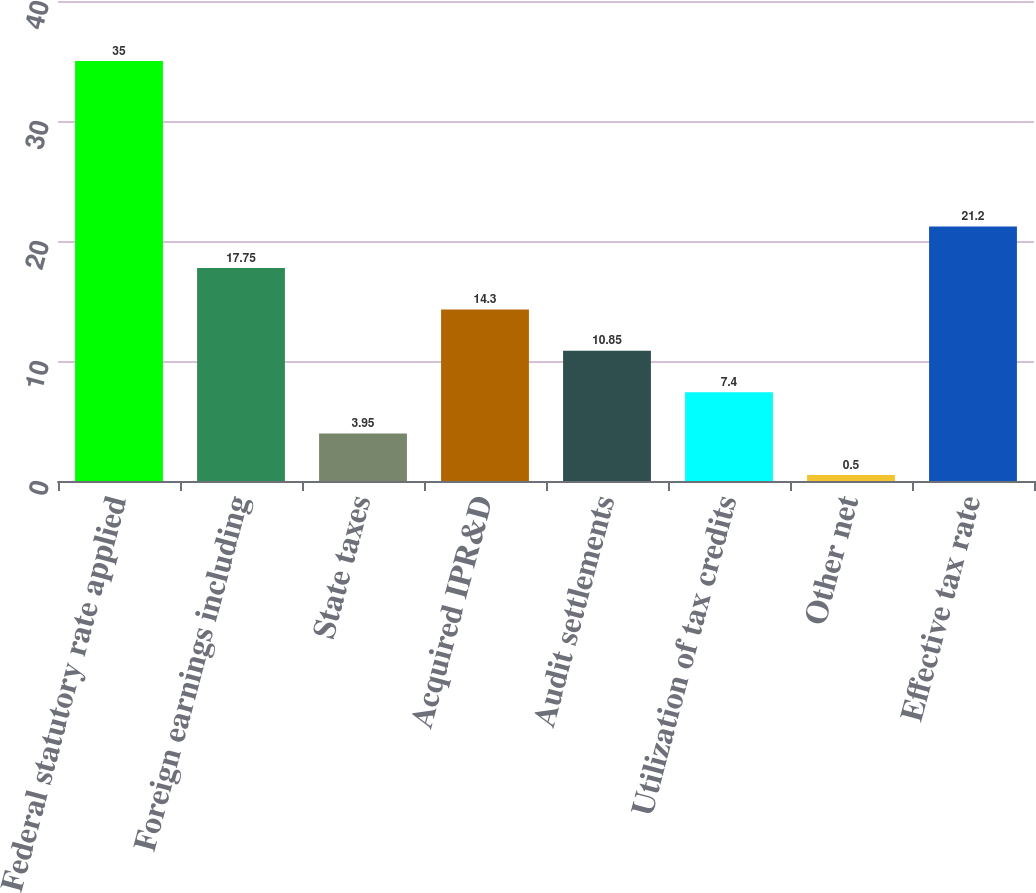Convert chart. <chart><loc_0><loc_0><loc_500><loc_500><bar_chart><fcel>Federal statutory rate applied<fcel>Foreign earnings including<fcel>State taxes<fcel>Acquired IPR&D<fcel>Audit settlements<fcel>Utilization of tax credits<fcel>Other net<fcel>Effective tax rate<nl><fcel>35<fcel>17.75<fcel>3.95<fcel>14.3<fcel>10.85<fcel>7.4<fcel>0.5<fcel>21.2<nl></chart> 